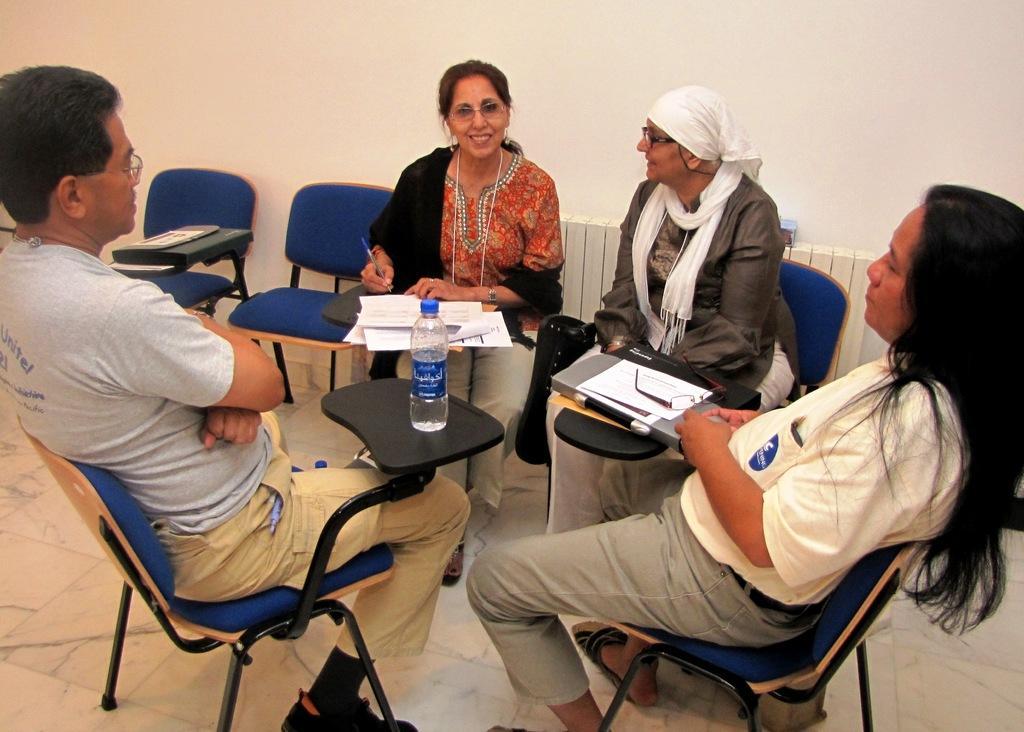In one or two sentences, can you explain what this image depicts? In the image we can see there are people who are sitting on chair and on the table there is a water bottle, papers. 